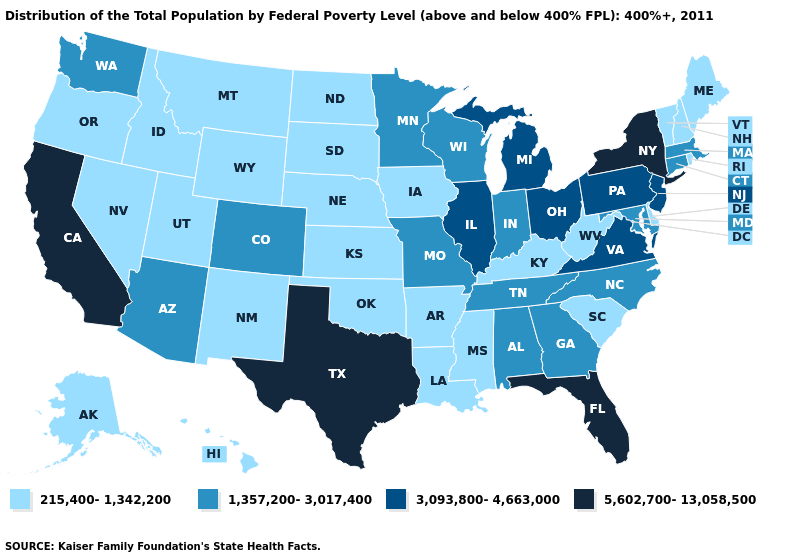Does the map have missing data?
Write a very short answer. No. What is the value of Hawaii?
Give a very brief answer. 215,400-1,342,200. What is the value of Hawaii?
Quick response, please. 215,400-1,342,200. Name the states that have a value in the range 3,093,800-4,663,000?
Write a very short answer. Illinois, Michigan, New Jersey, Ohio, Pennsylvania, Virginia. Does the map have missing data?
Quick response, please. No. Among the states that border Arizona , which have the highest value?
Concise answer only. California. Does Michigan have the lowest value in the MidWest?
Answer briefly. No. What is the lowest value in the USA?
Short answer required. 215,400-1,342,200. Among the states that border Maryland , does West Virginia have the lowest value?
Quick response, please. Yes. What is the highest value in the USA?
Be succinct. 5,602,700-13,058,500. Name the states that have a value in the range 3,093,800-4,663,000?
Quick response, please. Illinois, Michigan, New Jersey, Ohio, Pennsylvania, Virginia. Does the map have missing data?
Keep it brief. No. What is the value of Arkansas?
Short answer required. 215,400-1,342,200. Does Hawaii have the same value as Minnesota?
Be succinct. No. Does Wyoming have the highest value in the USA?
Be succinct. No. 